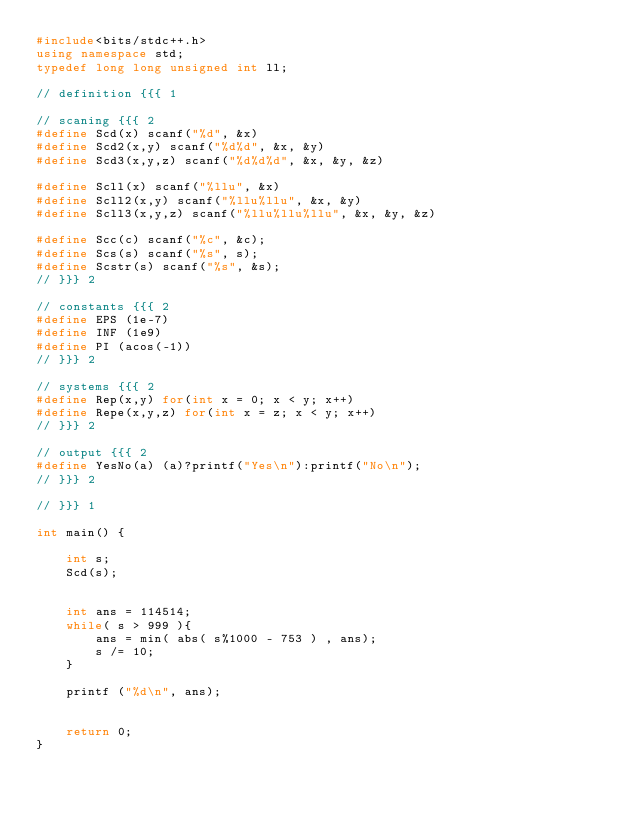<code> <loc_0><loc_0><loc_500><loc_500><_C++_>#include<bits/stdc++.h>
using namespace std;
typedef long long unsigned int ll;

// definition {{{ 1

// scaning {{{ 2
#define Scd(x) scanf("%d", &x)
#define Scd2(x,y) scanf("%d%d", &x, &y)
#define Scd3(x,y,z) scanf("%d%d%d", &x, &y, &z)

#define Scll(x) scanf("%llu", &x)
#define Scll2(x,y) scanf("%llu%llu", &x, &y)
#define Scll3(x,y,z) scanf("%llu%llu%llu", &x, &y, &z)

#define Scc(c) scanf("%c", &c);
#define Scs(s) scanf("%s", s);
#define Scstr(s) scanf("%s", &s);
// }}} 2

// constants {{{ 2
#define EPS (1e-7)
#define INF (1e9)
#define PI (acos(-1))
// }}} 2

// systems {{{ 2
#define Rep(x,y) for(int x = 0; x < y; x++)
#define Repe(x,y,z) for(int x = z; x < y; x++)
// }}} 2

// output {{{ 2
#define YesNo(a) (a)?printf("Yes\n"):printf("No\n");
// }}} 2

// }}} 1

int main() {

    int s;
    Scd(s);


    int ans = 114514;
    while( s > 999 ){
        ans = min( abs( s%1000 - 753 ) , ans);
        s /= 10;
    }

    printf ("%d\n", ans);


    return 0;
}

</code> 